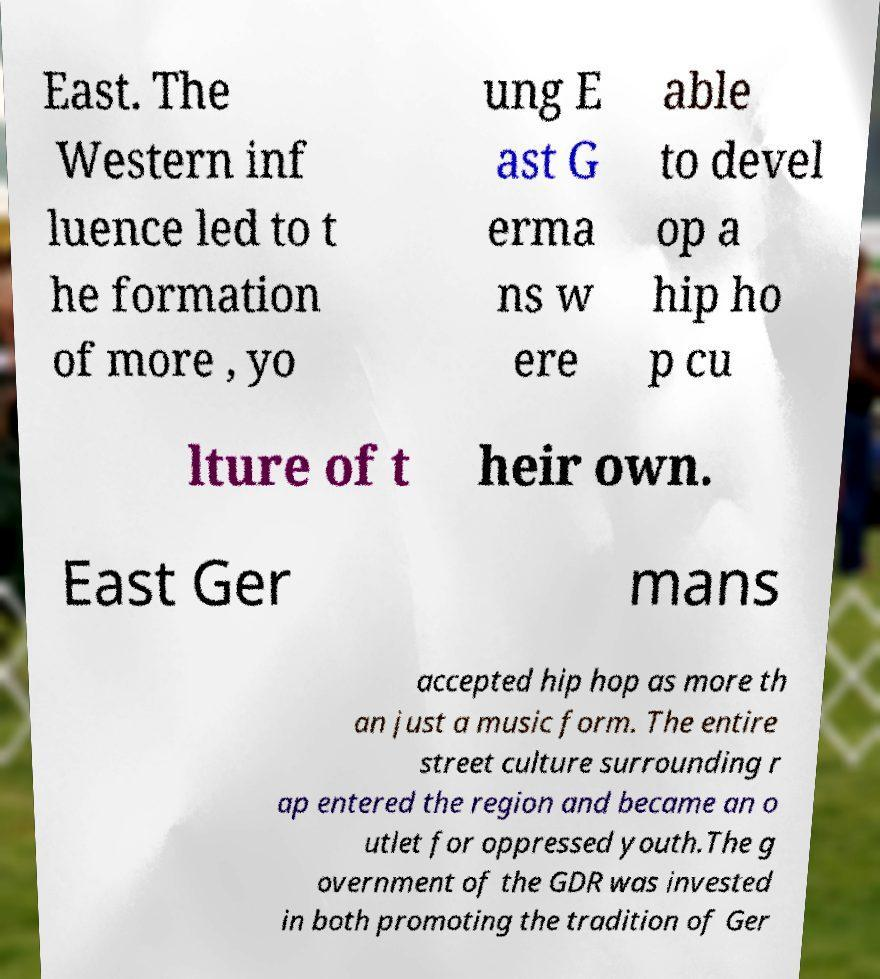Can you accurately transcribe the text from the provided image for me? East. The Western inf luence led to t he formation of more , yo ung E ast G erma ns w ere able to devel op a hip ho p cu lture of t heir own. East Ger mans accepted hip hop as more th an just a music form. The entire street culture surrounding r ap entered the region and became an o utlet for oppressed youth.The g overnment of the GDR was invested in both promoting the tradition of Ger 